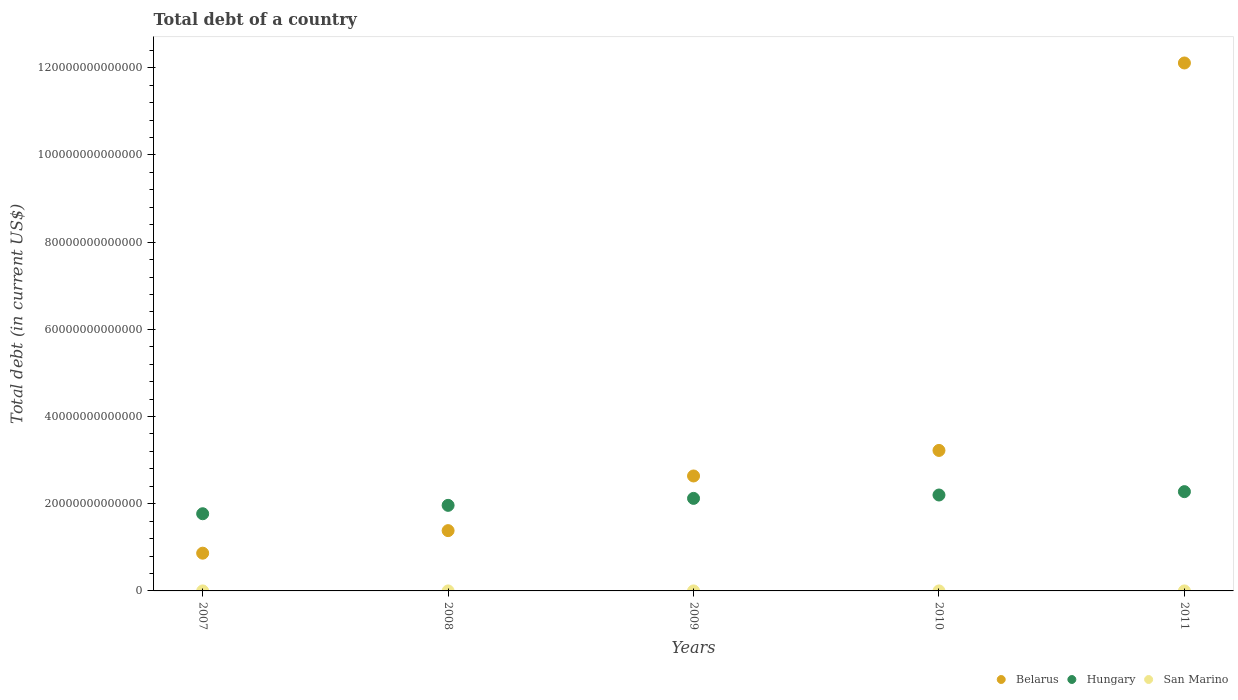What is the debt in Hungary in 2010?
Offer a very short reply. 2.20e+13. Across all years, what is the maximum debt in San Marino?
Your answer should be very brief. 7.80e+08. Across all years, what is the minimum debt in Hungary?
Your answer should be very brief. 1.77e+13. In which year was the debt in San Marino minimum?
Provide a succinct answer. 2011. What is the total debt in Belarus in the graph?
Keep it short and to the point. 2.02e+14. What is the difference between the debt in Belarus in 2007 and that in 2008?
Provide a succinct answer. -5.17e+12. What is the difference between the debt in Hungary in 2007 and the debt in San Marino in 2009?
Offer a very short reply. 1.77e+13. What is the average debt in San Marino per year?
Give a very brief answer. 7.16e+08. In the year 2010, what is the difference between the debt in Belarus and debt in San Marino?
Offer a very short reply. 3.22e+13. What is the ratio of the debt in San Marino in 2007 to that in 2009?
Your answer should be very brief. 1.1. Is the debt in Belarus in 2008 less than that in 2011?
Offer a very short reply. Yes. Is the difference between the debt in Belarus in 2007 and 2009 greater than the difference between the debt in San Marino in 2007 and 2009?
Offer a very short reply. No. What is the difference between the highest and the second highest debt in Hungary?
Offer a very short reply. 7.70e+11. What is the difference between the highest and the lowest debt in San Marino?
Offer a very short reply. 1.96e+08. In how many years, is the debt in Hungary greater than the average debt in Hungary taken over all years?
Offer a very short reply. 3. Is it the case that in every year, the sum of the debt in Belarus and debt in San Marino  is greater than the debt in Hungary?
Provide a succinct answer. No. Does the debt in Belarus monotonically increase over the years?
Give a very brief answer. Yes. Is the debt in San Marino strictly less than the debt in Belarus over the years?
Provide a succinct answer. Yes. How many years are there in the graph?
Provide a short and direct response. 5. What is the difference between two consecutive major ticks on the Y-axis?
Keep it short and to the point. 2.00e+13. Where does the legend appear in the graph?
Provide a short and direct response. Bottom right. How many legend labels are there?
Offer a terse response. 3. What is the title of the graph?
Your answer should be compact. Total debt of a country. Does "Portugal" appear as one of the legend labels in the graph?
Give a very brief answer. No. What is the label or title of the X-axis?
Give a very brief answer. Years. What is the label or title of the Y-axis?
Make the answer very short. Total debt (in current US$). What is the Total debt (in current US$) in Belarus in 2007?
Ensure brevity in your answer.  8.66e+12. What is the Total debt (in current US$) in Hungary in 2007?
Provide a short and direct response. 1.77e+13. What is the Total debt (in current US$) of San Marino in 2007?
Offer a terse response. 7.58e+08. What is the Total debt (in current US$) of Belarus in 2008?
Provide a succinct answer. 1.38e+13. What is the Total debt (in current US$) of Hungary in 2008?
Give a very brief answer. 1.96e+13. What is the Total debt (in current US$) of San Marino in 2008?
Give a very brief answer. 7.66e+08. What is the Total debt (in current US$) in Belarus in 2009?
Provide a short and direct response. 2.64e+13. What is the Total debt (in current US$) in Hungary in 2009?
Ensure brevity in your answer.  2.12e+13. What is the Total debt (in current US$) of San Marino in 2009?
Give a very brief answer. 6.90e+08. What is the Total debt (in current US$) in Belarus in 2010?
Your response must be concise. 3.22e+13. What is the Total debt (in current US$) of Hungary in 2010?
Ensure brevity in your answer.  2.20e+13. What is the Total debt (in current US$) of San Marino in 2010?
Ensure brevity in your answer.  7.80e+08. What is the Total debt (in current US$) in Belarus in 2011?
Offer a very short reply. 1.21e+14. What is the Total debt (in current US$) in Hungary in 2011?
Your response must be concise. 2.28e+13. What is the Total debt (in current US$) in San Marino in 2011?
Your answer should be very brief. 5.84e+08. Across all years, what is the maximum Total debt (in current US$) of Belarus?
Provide a succinct answer. 1.21e+14. Across all years, what is the maximum Total debt (in current US$) in Hungary?
Provide a short and direct response. 2.28e+13. Across all years, what is the maximum Total debt (in current US$) in San Marino?
Offer a terse response. 7.80e+08. Across all years, what is the minimum Total debt (in current US$) in Belarus?
Your answer should be compact. 8.66e+12. Across all years, what is the minimum Total debt (in current US$) of Hungary?
Ensure brevity in your answer.  1.77e+13. Across all years, what is the minimum Total debt (in current US$) of San Marino?
Your answer should be compact. 5.84e+08. What is the total Total debt (in current US$) in Belarus in the graph?
Provide a succinct answer. 2.02e+14. What is the total Total debt (in current US$) of Hungary in the graph?
Provide a succinct answer. 1.03e+14. What is the total Total debt (in current US$) in San Marino in the graph?
Ensure brevity in your answer.  3.58e+09. What is the difference between the Total debt (in current US$) of Belarus in 2007 and that in 2008?
Give a very brief answer. -5.17e+12. What is the difference between the Total debt (in current US$) of Hungary in 2007 and that in 2008?
Provide a short and direct response. -1.92e+12. What is the difference between the Total debt (in current US$) of San Marino in 2007 and that in 2008?
Keep it short and to the point. -8.04e+06. What is the difference between the Total debt (in current US$) in Belarus in 2007 and that in 2009?
Your answer should be compact. -1.77e+13. What is the difference between the Total debt (in current US$) in Hungary in 2007 and that in 2009?
Your response must be concise. -3.52e+12. What is the difference between the Total debt (in current US$) in San Marino in 2007 and that in 2009?
Keep it short and to the point. 6.80e+07. What is the difference between the Total debt (in current US$) of Belarus in 2007 and that in 2010?
Your response must be concise. -2.36e+13. What is the difference between the Total debt (in current US$) of Hungary in 2007 and that in 2010?
Your answer should be compact. -4.30e+12. What is the difference between the Total debt (in current US$) in San Marino in 2007 and that in 2010?
Provide a short and direct response. -2.23e+07. What is the difference between the Total debt (in current US$) in Belarus in 2007 and that in 2011?
Make the answer very short. -1.12e+14. What is the difference between the Total debt (in current US$) in Hungary in 2007 and that in 2011?
Provide a succinct answer. -5.07e+12. What is the difference between the Total debt (in current US$) in San Marino in 2007 and that in 2011?
Keep it short and to the point. 1.74e+08. What is the difference between the Total debt (in current US$) of Belarus in 2008 and that in 2009?
Give a very brief answer. -1.25e+13. What is the difference between the Total debt (in current US$) in Hungary in 2008 and that in 2009?
Offer a very short reply. -1.60e+12. What is the difference between the Total debt (in current US$) in San Marino in 2008 and that in 2009?
Your response must be concise. 7.60e+07. What is the difference between the Total debt (in current US$) in Belarus in 2008 and that in 2010?
Offer a very short reply. -1.84e+13. What is the difference between the Total debt (in current US$) in Hungary in 2008 and that in 2010?
Keep it short and to the point. -2.37e+12. What is the difference between the Total debt (in current US$) in San Marino in 2008 and that in 2010?
Offer a very short reply. -1.42e+07. What is the difference between the Total debt (in current US$) in Belarus in 2008 and that in 2011?
Make the answer very short. -1.07e+14. What is the difference between the Total debt (in current US$) in Hungary in 2008 and that in 2011?
Offer a very short reply. -3.14e+12. What is the difference between the Total debt (in current US$) in San Marino in 2008 and that in 2011?
Your answer should be very brief. 1.82e+08. What is the difference between the Total debt (in current US$) of Belarus in 2009 and that in 2010?
Your answer should be very brief. -5.86e+12. What is the difference between the Total debt (in current US$) of Hungary in 2009 and that in 2010?
Make the answer very short. -7.75e+11. What is the difference between the Total debt (in current US$) of San Marino in 2009 and that in 2010?
Your response must be concise. -9.03e+07. What is the difference between the Total debt (in current US$) in Belarus in 2009 and that in 2011?
Offer a very short reply. -9.47e+13. What is the difference between the Total debt (in current US$) in Hungary in 2009 and that in 2011?
Your answer should be compact. -1.54e+12. What is the difference between the Total debt (in current US$) of San Marino in 2009 and that in 2011?
Give a very brief answer. 1.06e+08. What is the difference between the Total debt (in current US$) in Belarus in 2010 and that in 2011?
Offer a very short reply. -8.89e+13. What is the difference between the Total debt (in current US$) of Hungary in 2010 and that in 2011?
Give a very brief answer. -7.70e+11. What is the difference between the Total debt (in current US$) in San Marino in 2010 and that in 2011?
Your answer should be very brief. 1.96e+08. What is the difference between the Total debt (in current US$) in Belarus in 2007 and the Total debt (in current US$) in Hungary in 2008?
Give a very brief answer. -1.10e+13. What is the difference between the Total debt (in current US$) of Belarus in 2007 and the Total debt (in current US$) of San Marino in 2008?
Your answer should be very brief. 8.66e+12. What is the difference between the Total debt (in current US$) of Hungary in 2007 and the Total debt (in current US$) of San Marino in 2008?
Provide a succinct answer. 1.77e+13. What is the difference between the Total debt (in current US$) of Belarus in 2007 and the Total debt (in current US$) of Hungary in 2009?
Provide a short and direct response. -1.26e+13. What is the difference between the Total debt (in current US$) of Belarus in 2007 and the Total debt (in current US$) of San Marino in 2009?
Offer a very short reply. 8.66e+12. What is the difference between the Total debt (in current US$) of Hungary in 2007 and the Total debt (in current US$) of San Marino in 2009?
Offer a terse response. 1.77e+13. What is the difference between the Total debt (in current US$) in Belarus in 2007 and the Total debt (in current US$) in Hungary in 2010?
Your response must be concise. -1.33e+13. What is the difference between the Total debt (in current US$) in Belarus in 2007 and the Total debt (in current US$) in San Marino in 2010?
Offer a very short reply. 8.66e+12. What is the difference between the Total debt (in current US$) of Hungary in 2007 and the Total debt (in current US$) of San Marino in 2010?
Your answer should be very brief. 1.77e+13. What is the difference between the Total debt (in current US$) of Belarus in 2007 and the Total debt (in current US$) of Hungary in 2011?
Provide a short and direct response. -1.41e+13. What is the difference between the Total debt (in current US$) of Belarus in 2007 and the Total debt (in current US$) of San Marino in 2011?
Your answer should be very brief. 8.66e+12. What is the difference between the Total debt (in current US$) in Hungary in 2007 and the Total debt (in current US$) in San Marino in 2011?
Offer a terse response. 1.77e+13. What is the difference between the Total debt (in current US$) in Belarus in 2008 and the Total debt (in current US$) in Hungary in 2009?
Offer a terse response. -7.40e+12. What is the difference between the Total debt (in current US$) of Belarus in 2008 and the Total debt (in current US$) of San Marino in 2009?
Keep it short and to the point. 1.38e+13. What is the difference between the Total debt (in current US$) of Hungary in 2008 and the Total debt (in current US$) of San Marino in 2009?
Keep it short and to the point. 1.96e+13. What is the difference between the Total debt (in current US$) of Belarus in 2008 and the Total debt (in current US$) of Hungary in 2010?
Provide a short and direct response. -8.17e+12. What is the difference between the Total debt (in current US$) in Belarus in 2008 and the Total debt (in current US$) in San Marino in 2010?
Ensure brevity in your answer.  1.38e+13. What is the difference between the Total debt (in current US$) of Hungary in 2008 and the Total debt (in current US$) of San Marino in 2010?
Provide a short and direct response. 1.96e+13. What is the difference between the Total debt (in current US$) in Belarus in 2008 and the Total debt (in current US$) in Hungary in 2011?
Provide a succinct answer. -8.94e+12. What is the difference between the Total debt (in current US$) in Belarus in 2008 and the Total debt (in current US$) in San Marino in 2011?
Your response must be concise. 1.38e+13. What is the difference between the Total debt (in current US$) in Hungary in 2008 and the Total debt (in current US$) in San Marino in 2011?
Provide a short and direct response. 1.96e+13. What is the difference between the Total debt (in current US$) of Belarus in 2009 and the Total debt (in current US$) of Hungary in 2010?
Offer a terse response. 4.37e+12. What is the difference between the Total debt (in current US$) of Belarus in 2009 and the Total debt (in current US$) of San Marino in 2010?
Ensure brevity in your answer.  2.64e+13. What is the difference between the Total debt (in current US$) in Hungary in 2009 and the Total debt (in current US$) in San Marino in 2010?
Keep it short and to the point. 2.12e+13. What is the difference between the Total debt (in current US$) in Belarus in 2009 and the Total debt (in current US$) in Hungary in 2011?
Your response must be concise. 3.60e+12. What is the difference between the Total debt (in current US$) in Belarus in 2009 and the Total debt (in current US$) in San Marino in 2011?
Your answer should be very brief. 2.64e+13. What is the difference between the Total debt (in current US$) in Hungary in 2009 and the Total debt (in current US$) in San Marino in 2011?
Ensure brevity in your answer.  2.12e+13. What is the difference between the Total debt (in current US$) in Belarus in 2010 and the Total debt (in current US$) in Hungary in 2011?
Ensure brevity in your answer.  9.46e+12. What is the difference between the Total debt (in current US$) in Belarus in 2010 and the Total debt (in current US$) in San Marino in 2011?
Give a very brief answer. 3.22e+13. What is the difference between the Total debt (in current US$) of Hungary in 2010 and the Total debt (in current US$) of San Marino in 2011?
Your answer should be very brief. 2.20e+13. What is the average Total debt (in current US$) of Belarus per year?
Provide a succinct answer. 4.04e+13. What is the average Total debt (in current US$) of Hungary per year?
Your answer should be very brief. 2.07e+13. What is the average Total debt (in current US$) in San Marino per year?
Your response must be concise. 7.16e+08. In the year 2007, what is the difference between the Total debt (in current US$) in Belarus and Total debt (in current US$) in Hungary?
Make the answer very short. -9.05e+12. In the year 2007, what is the difference between the Total debt (in current US$) in Belarus and Total debt (in current US$) in San Marino?
Offer a terse response. 8.66e+12. In the year 2007, what is the difference between the Total debt (in current US$) of Hungary and Total debt (in current US$) of San Marino?
Offer a terse response. 1.77e+13. In the year 2008, what is the difference between the Total debt (in current US$) in Belarus and Total debt (in current US$) in Hungary?
Your answer should be compact. -5.80e+12. In the year 2008, what is the difference between the Total debt (in current US$) of Belarus and Total debt (in current US$) of San Marino?
Give a very brief answer. 1.38e+13. In the year 2008, what is the difference between the Total debt (in current US$) in Hungary and Total debt (in current US$) in San Marino?
Make the answer very short. 1.96e+13. In the year 2009, what is the difference between the Total debt (in current US$) in Belarus and Total debt (in current US$) in Hungary?
Ensure brevity in your answer.  5.14e+12. In the year 2009, what is the difference between the Total debt (in current US$) of Belarus and Total debt (in current US$) of San Marino?
Your answer should be very brief. 2.64e+13. In the year 2009, what is the difference between the Total debt (in current US$) of Hungary and Total debt (in current US$) of San Marino?
Offer a very short reply. 2.12e+13. In the year 2010, what is the difference between the Total debt (in current US$) in Belarus and Total debt (in current US$) in Hungary?
Provide a short and direct response. 1.02e+13. In the year 2010, what is the difference between the Total debt (in current US$) in Belarus and Total debt (in current US$) in San Marino?
Provide a succinct answer. 3.22e+13. In the year 2010, what is the difference between the Total debt (in current US$) of Hungary and Total debt (in current US$) of San Marino?
Provide a short and direct response. 2.20e+13. In the year 2011, what is the difference between the Total debt (in current US$) in Belarus and Total debt (in current US$) in Hungary?
Your response must be concise. 9.83e+13. In the year 2011, what is the difference between the Total debt (in current US$) of Belarus and Total debt (in current US$) of San Marino?
Your answer should be very brief. 1.21e+14. In the year 2011, what is the difference between the Total debt (in current US$) in Hungary and Total debt (in current US$) in San Marino?
Keep it short and to the point. 2.28e+13. What is the ratio of the Total debt (in current US$) in Belarus in 2007 to that in 2008?
Offer a terse response. 0.63. What is the ratio of the Total debt (in current US$) in Hungary in 2007 to that in 2008?
Make the answer very short. 0.9. What is the ratio of the Total debt (in current US$) in Belarus in 2007 to that in 2009?
Give a very brief answer. 0.33. What is the ratio of the Total debt (in current US$) in Hungary in 2007 to that in 2009?
Your response must be concise. 0.83. What is the ratio of the Total debt (in current US$) in San Marino in 2007 to that in 2009?
Offer a very short reply. 1.1. What is the ratio of the Total debt (in current US$) in Belarus in 2007 to that in 2010?
Provide a short and direct response. 0.27. What is the ratio of the Total debt (in current US$) of Hungary in 2007 to that in 2010?
Make the answer very short. 0.8. What is the ratio of the Total debt (in current US$) in San Marino in 2007 to that in 2010?
Make the answer very short. 0.97. What is the ratio of the Total debt (in current US$) of Belarus in 2007 to that in 2011?
Your answer should be very brief. 0.07. What is the ratio of the Total debt (in current US$) in Hungary in 2007 to that in 2011?
Provide a succinct answer. 0.78. What is the ratio of the Total debt (in current US$) in San Marino in 2007 to that in 2011?
Keep it short and to the point. 1.3. What is the ratio of the Total debt (in current US$) of Belarus in 2008 to that in 2009?
Offer a terse response. 0.52. What is the ratio of the Total debt (in current US$) in Hungary in 2008 to that in 2009?
Give a very brief answer. 0.92. What is the ratio of the Total debt (in current US$) of San Marino in 2008 to that in 2009?
Offer a very short reply. 1.11. What is the ratio of the Total debt (in current US$) of Belarus in 2008 to that in 2010?
Your response must be concise. 0.43. What is the ratio of the Total debt (in current US$) in Hungary in 2008 to that in 2010?
Ensure brevity in your answer.  0.89. What is the ratio of the Total debt (in current US$) in San Marino in 2008 to that in 2010?
Provide a succinct answer. 0.98. What is the ratio of the Total debt (in current US$) in Belarus in 2008 to that in 2011?
Offer a terse response. 0.11. What is the ratio of the Total debt (in current US$) of Hungary in 2008 to that in 2011?
Offer a very short reply. 0.86. What is the ratio of the Total debt (in current US$) in San Marino in 2008 to that in 2011?
Your response must be concise. 1.31. What is the ratio of the Total debt (in current US$) in Belarus in 2009 to that in 2010?
Your answer should be compact. 0.82. What is the ratio of the Total debt (in current US$) in Hungary in 2009 to that in 2010?
Ensure brevity in your answer.  0.96. What is the ratio of the Total debt (in current US$) of San Marino in 2009 to that in 2010?
Ensure brevity in your answer.  0.88. What is the ratio of the Total debt (in current US$) of Belarus in 2009 to that in 2011?
Keep it short and to the point. 0.22. What is the ratio of the Total debt (in current US$) in Hungary in 2009 to that in 2011?
Your answer should be compact. 0.93. What is the ratio of the Total debt (in current US$) in San Marino in 2009 to that in 2011?
Offer a very short reply. 1.18. What is the ratio of the Total debt (in current US$) in Belarus in 2010 to that in 2011?
Provide a short and direct response. 0.27. What is the ratio of the Total debt (in current US$) of Hungary in 2010 to that in 2011?
Ensure brevity in your answer.  0.97. What is the ratio of the Total debt (in current US$) of San Marino in 2010 to that in 2011?
Offer a terse response. 1.34. What is the difference between the highest and the second highest Total debt (in current US$) in Belarus?
Ensure brevity in your answer.  8.89e+13. What is the difference between the highest and the second highest Total debt (in current US$) of Hungary?
Provide a short and direct response. 7.70e+11. What is the difference between the highest and the second highest Total debt (in current US$) in San Marino?
Provide a short and direct response. 1.42e+07. What is the difference between the highest and the lowest Total debt (in current US$) of Belarus?
Offer a terse response. 1.12e+14. What is the difference between the highest and the lowest Total debt (in current US$) in Hungary?
Make the answer very short. 5.07e+12. What is the difference between the highest and the lowest Total debt (in current US$) of San Marino?
Offer a terse response. 1.96e+08. 